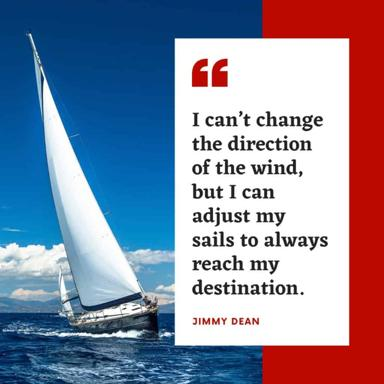How could the choice of a sailboat as imagery enhance the meaning of the quote? The sailboat is a fitting metaphor for the message in the quote. Sailboats rely on adjusting their sails to navigate according to the wind’s direction, much like how we must adapt to life's circumstances that are beyond our control. This imagery enhances the quote by illustrating the practical application of adjusting one's approach to reach desired outcomes despite external challenges. Is there a specific type of situation where this quote and imagery would be particularly impactful? This quote, paired with the sailboat imagery, would be particularly impactful in times of personal or professional transition or uncertainty. For example, during career changes, moving to new places, or navigating complex personal relationships, this message encourages maintaining focus on one’s goals and adapting strategies, reminding us that we hold the power to steer through these changes successfully. 